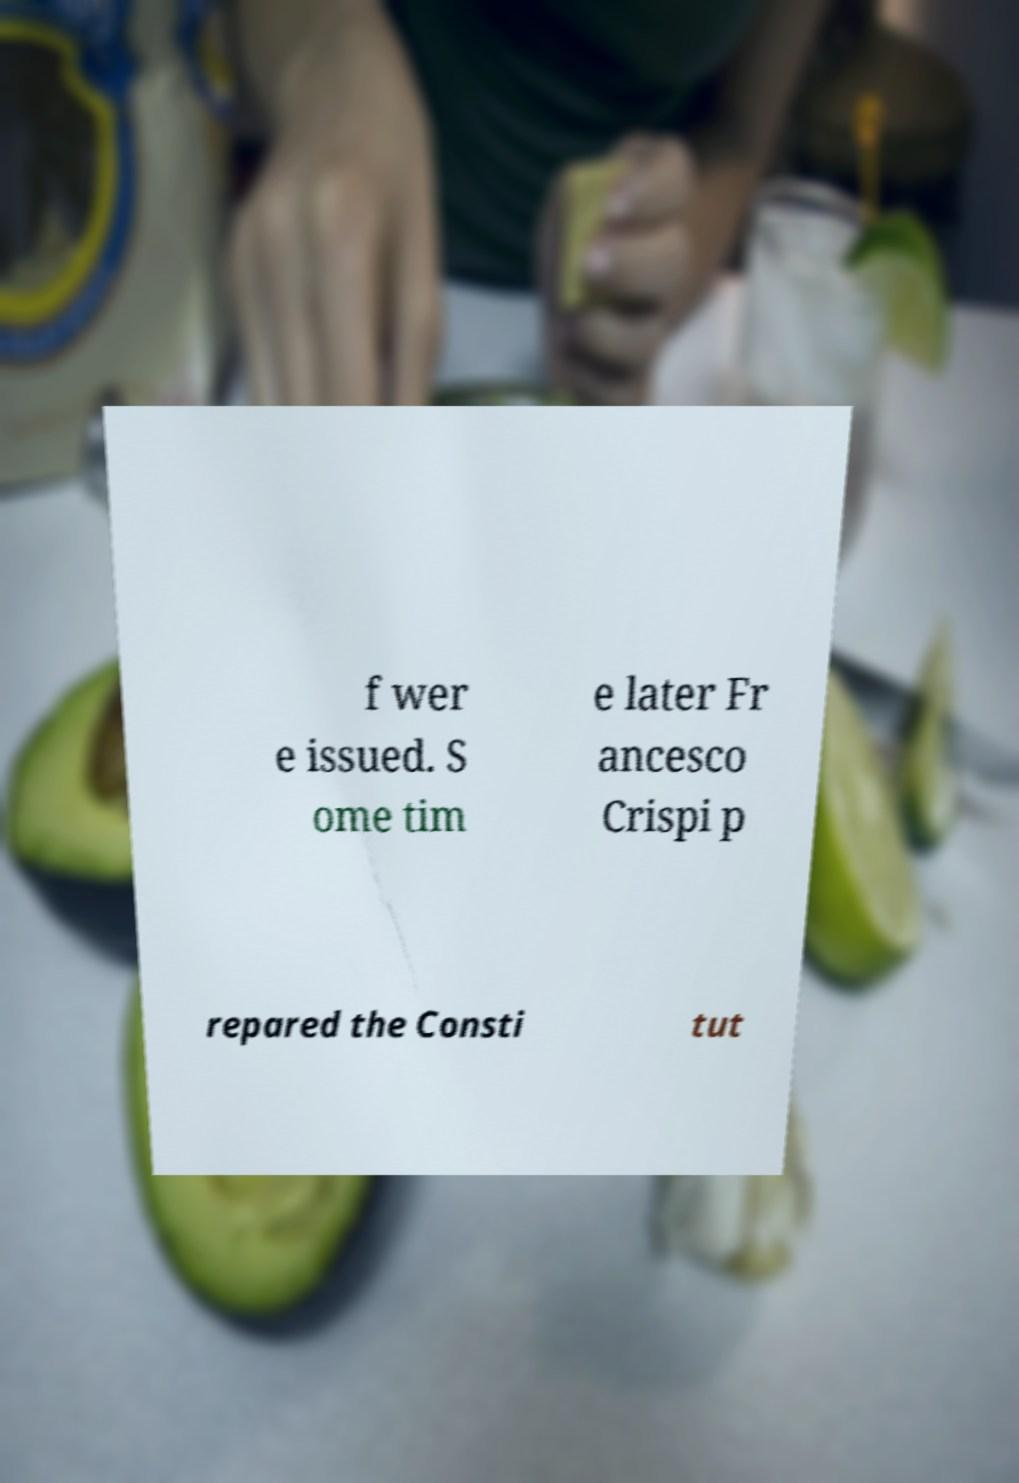Could you extract and type out the text from this image? f wer e issued. S ome tim e later Fr ancesco Crispi p repared the Consti tut 